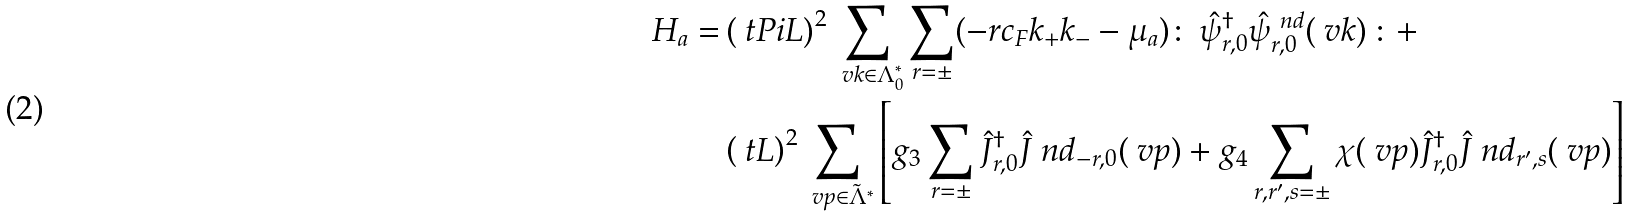<formula> <loc_0><loc_0><loc_500><loc_500>H _ { a } = & \left ( \ t P i L \right ) ^ { 2 } \sum _ { \ v k \in \Lambda ^ { * } _ { 0 } } \sum _ { r = \pm } ( - r c _ { F } k _ { + } k _ { - } - \mu _ { a } ) \colon \, \hat { \psi } ^ { \dag } _ { r , 0 } \hat { \psi } ^ { \ n d } _ { r , 0 } ( \ v k ) \, \colon + \\ & \left ( \ t L \right ) ^ { 2 } \sum _ { \ v p \in \tilde { \Lambda } ^ { * } } \left [ g _ { 3 } \sum _ { r = \pm } \hat { J } ^ { \dag } _ { r , 0 } \hat { J } ^ { \ } n d _ { - r , 0 } ( \ v p ) + g _ { 4 } \sum _ { r , r ^ { \prime } , s = \pm } \chi ( \ v p ) \hat { J } ^ { \dag } _ { r , 0 } \hat { J } ^ { \ } n d _ { r ^ { \prime } , s } ( \ v p ) \right ]</formula> 